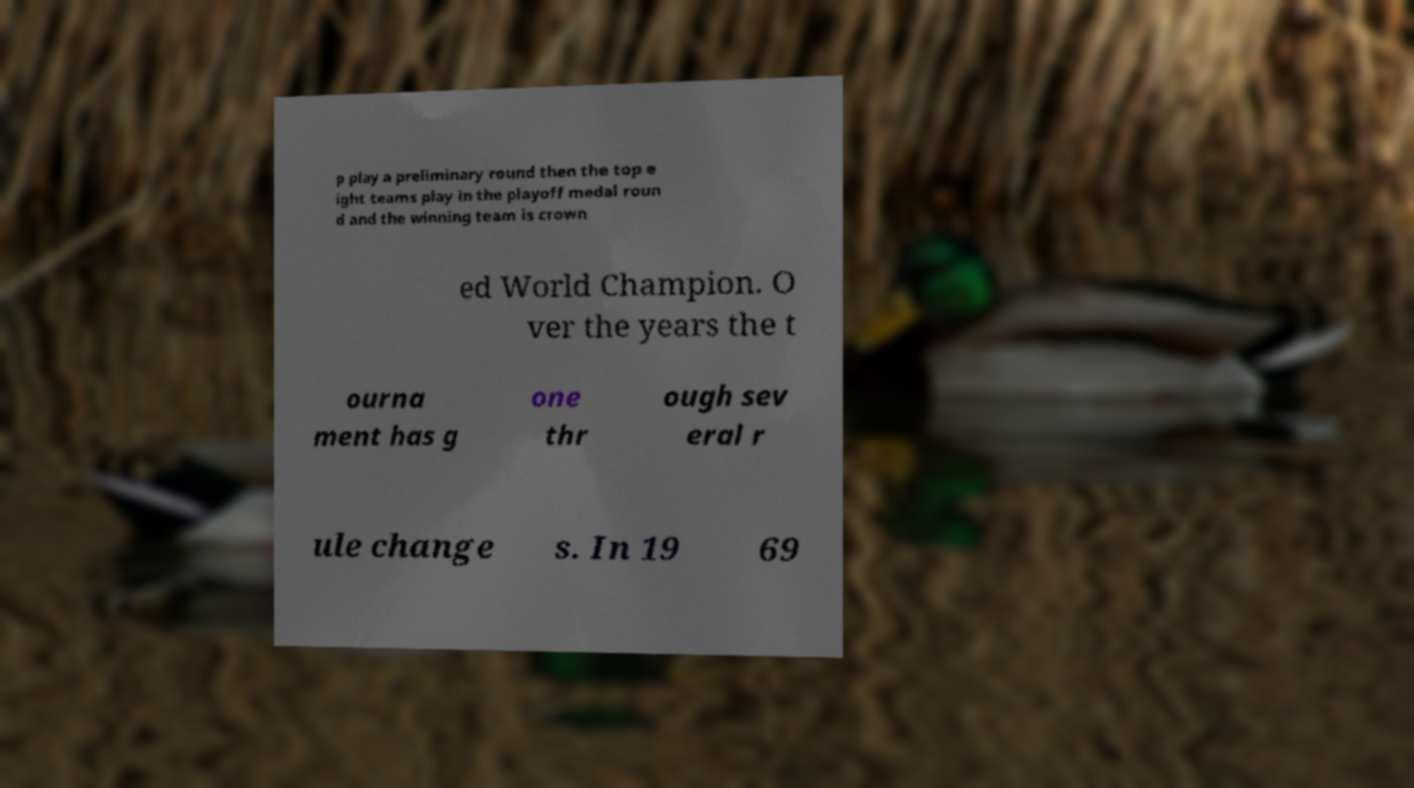For documentation purposes, I need the text within this image transcribed. Could you provide that? p play a preliminary round then the top e ight teams play in the playoff medal roun d and the winning team is crown ed World Champion. O ver the years the t ourna ment has g one thr ough sev eral r ule change s. In 19 69 